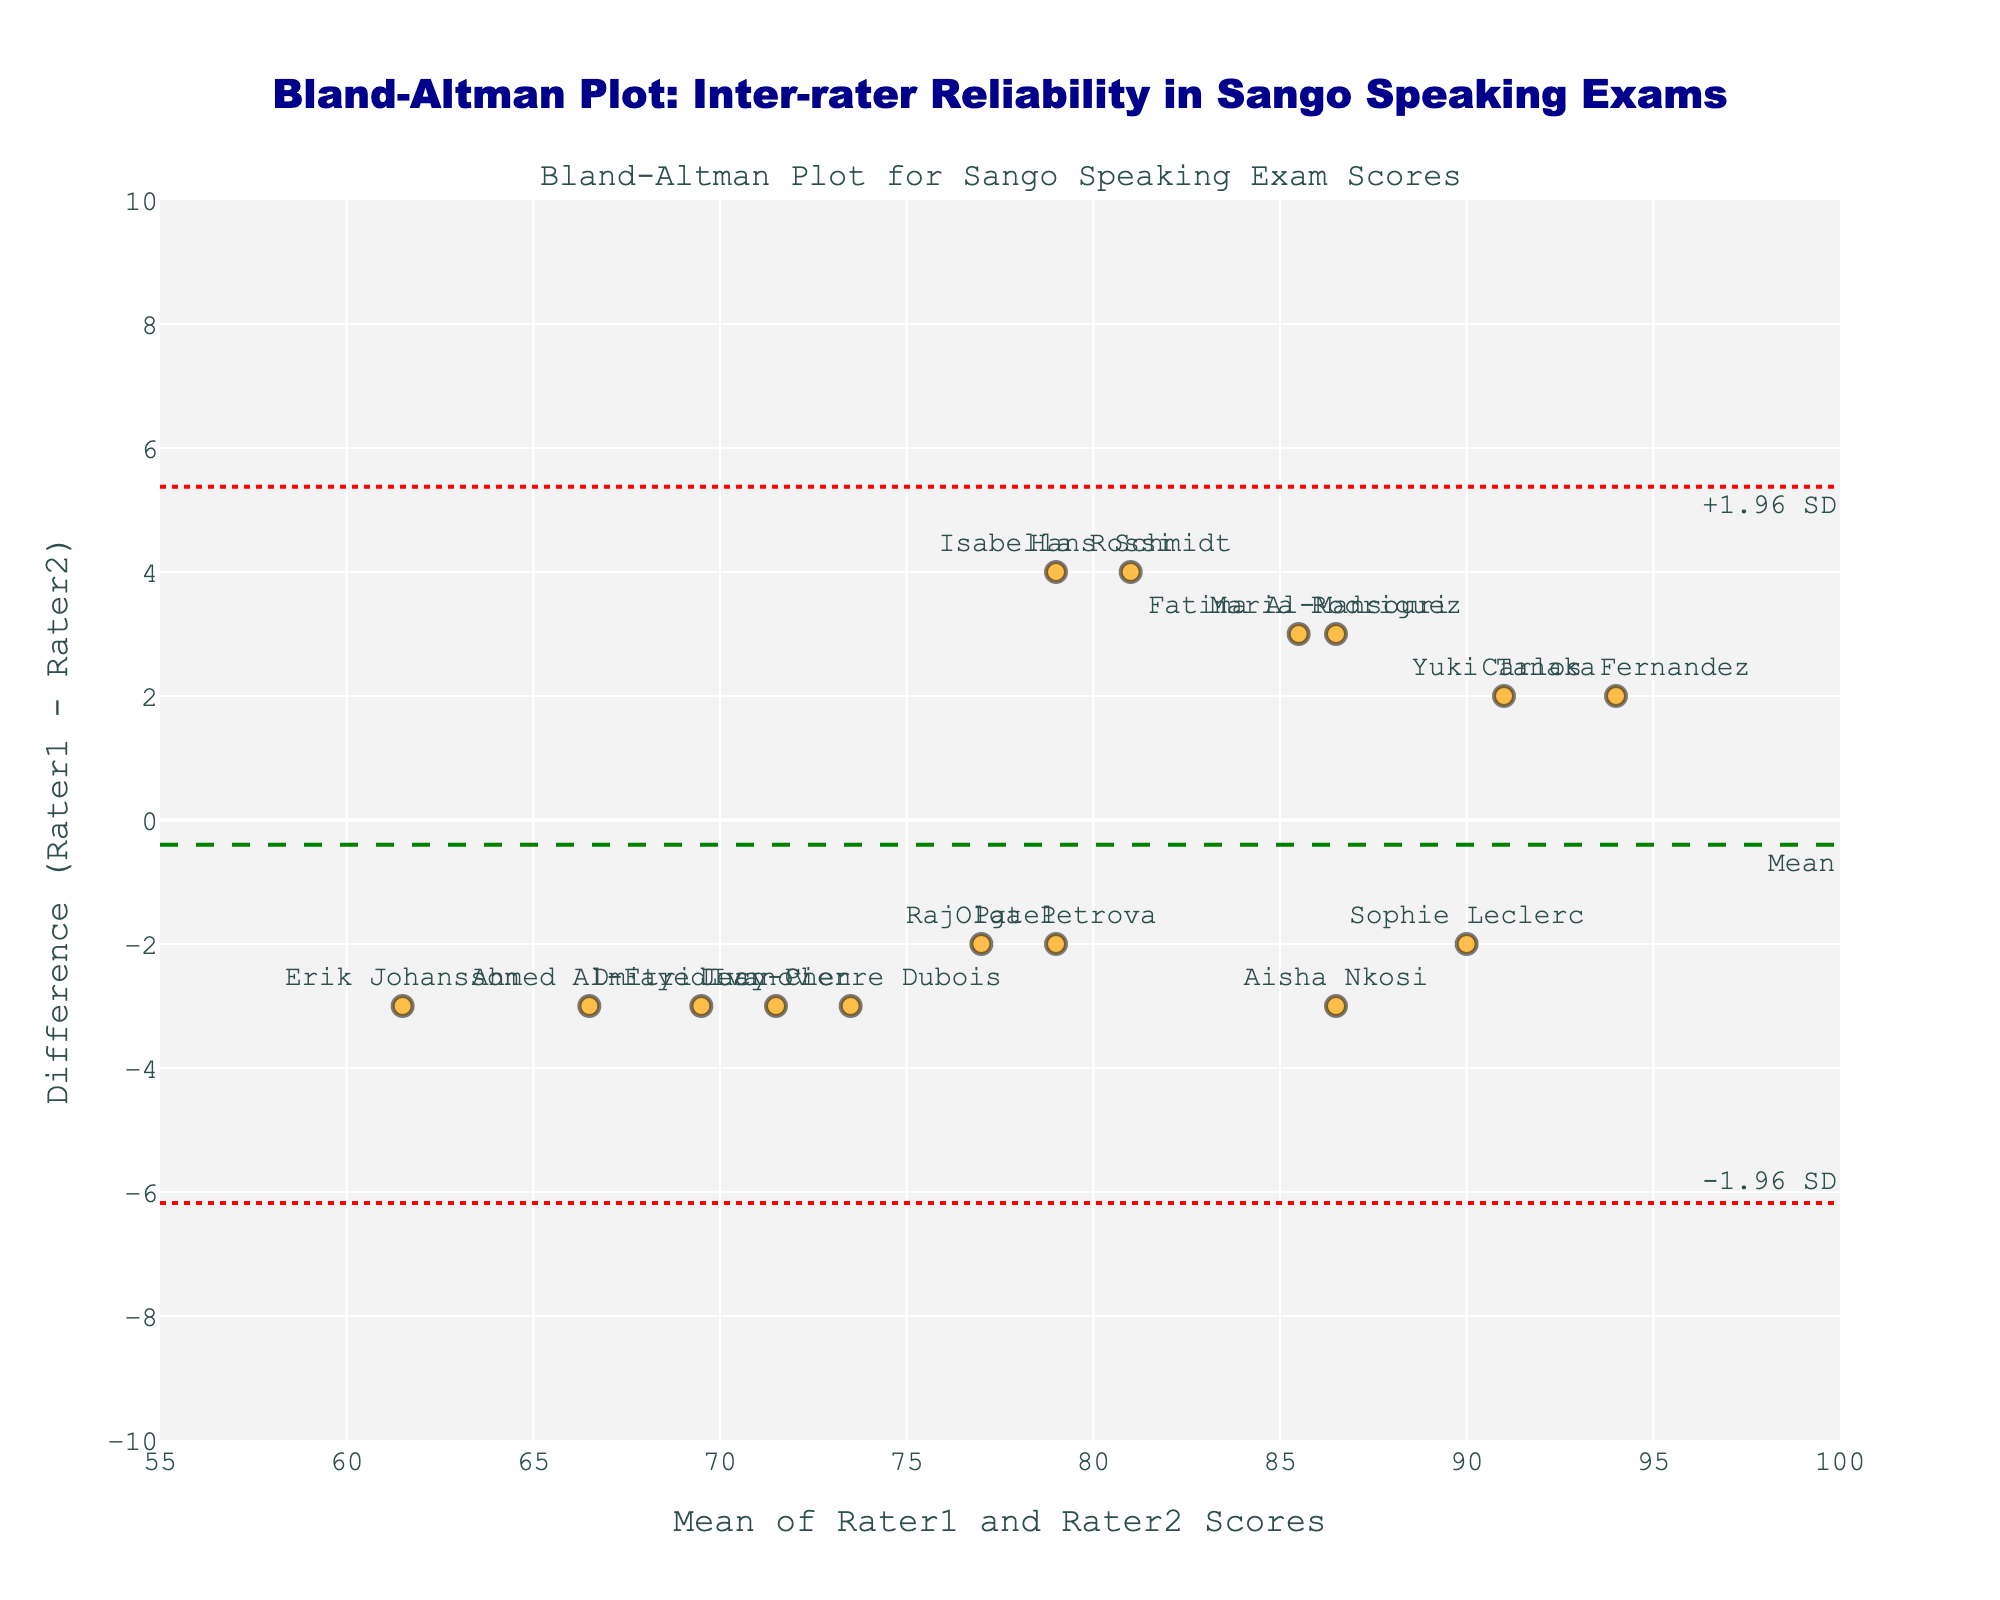What is the title of the plot? The title of the plot is located at the top and is typically formatted larger than other text to catch the viewer's attention. In this case, the title specifically indicates the figure's purpose.
Answer: Bland-Altman Plot: Inter-rater Reliability in Sango Speaking Exams What does the y-axis represent? The y-axis title of a plot describes what the vertical dimension of the graph illustrates. Here, it indicates a key aspect of inter-rater reliability.
Answer: Difference (Rater1 - Rater2) How many expats' exam scores are included in the plot? Each data point on the plot represents an individual expat. The plot has one point per expat, and names are attached to each point for identification. By counting these points, we can determine how many expats' scores are included.
Answer: 15 What is the range of the x-axis in the plot? The x-axis displays the mean scores of two raters for each expat. The visual range can be identified by examining the plot's x-axis ticks and labels.
Answer: 55 to 100 What is the color of the markers representing the exam scores? The color of the markers is a visual aspect that is typically chosen to enhance readability and distinguish data points. In this plot, the particular color used for the markers can be identified by observing the plot.
Answer: Orange What value is represented by the green dashed line? The green dashed line typically represents a calculated average or central tendency of the differences. By identifying the placement of this line, we can understand which specific value it signifies.
Answer: Mean difference What are the values of the upper and lower limits of agreement (LoA)? The upper and lower LoA are indicated by red dotted lines marked with ±1.96 SD annotations. These values can be determined by locating and reading the positions of these lines on the y-axis.
Answer: Upper LoA: ~4.99, Lower LoA: ~-4.79 Which expat has the largest positive difference between the raters' scores? To answer this, we identify the highest data point on the y-axis, as it reflects the largest positive difference between Rater1 and Rater2. The associated name label reveals the expat.
Answer: Aisha Nkosi Which two expats have exactly the same mean score of 85? By pinpointing two markers that share an x-axis position of 85, we determine these expats. The adjacent names indicate which expats share this mean score.
Answer: Maria Rodriguez and Aisha Nkosi How does Erik Johansson's score difference compare to the mean difference? To compare Erik Johansson's score difference with the mean difference, locate his data point and compare its y-axis value to the mean difference marked by the green dashed line.
Answer: Below the mean 